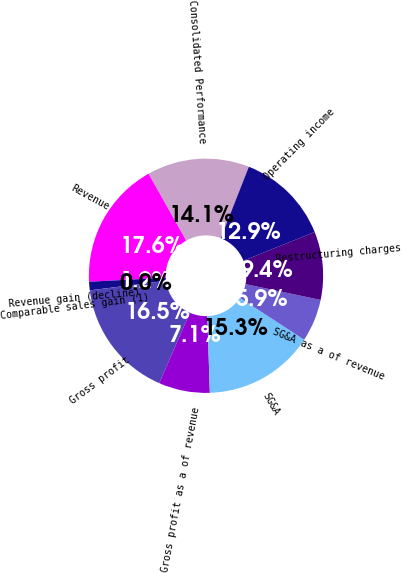<chart> <loc_0><loc_0><loc_500><loc_500><pie_chart><fcel>Consolidated Performance<fcel>Revenue<fcel>Revenue gain (decline)<fcel>Comparable sales gain (1)<fcel>Gross profit<fcel>Gross profit as a of revenue<fcel>SG&A<fcel>SG&A as a of revenue<fcel>Restructuring charges<fcel>Operating income<nl><fcel>14.12%<fcel>17.65%<fcel>1.18%<fcel>0.0%<fcel>16.47%<fcel>7.06%<fcel>15.29%<fcel>5.88%<fcel>9.41%<fcel>12.94%<nl></chart> 